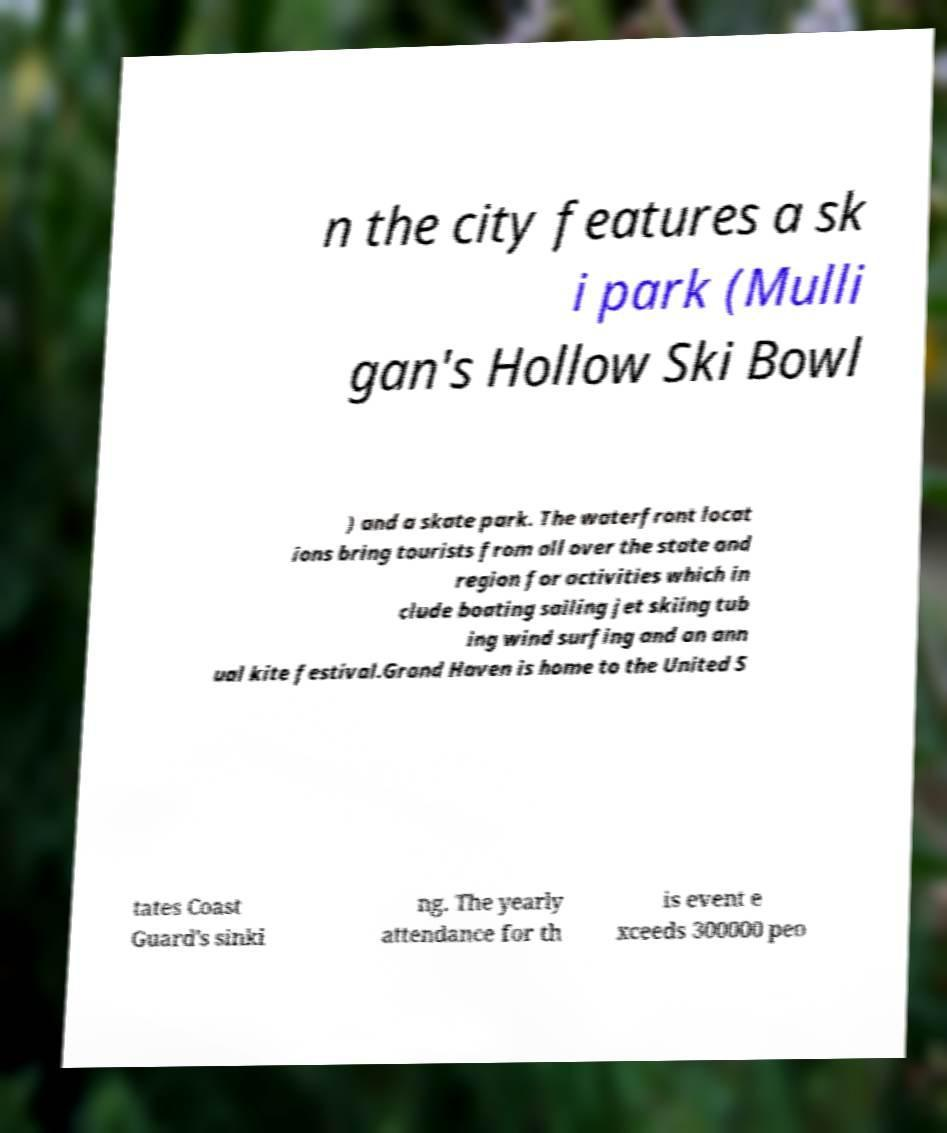For documentation purposes, I need the text within this image transcribed. Could you provide that? n the city features a sk i park (Mulli gan's Hollow Ski Bowl ) and a skate park. The waterfront locat ions bring tourists from all over the state and region for activities which in clude boating sailing jet skiing tub ing wind surfing and an ann ual kite festival.Grand Haven is home to the United S tates Coast Guard's sinki ng. The yearly attendance for th is event e xceeds 300000 peo 